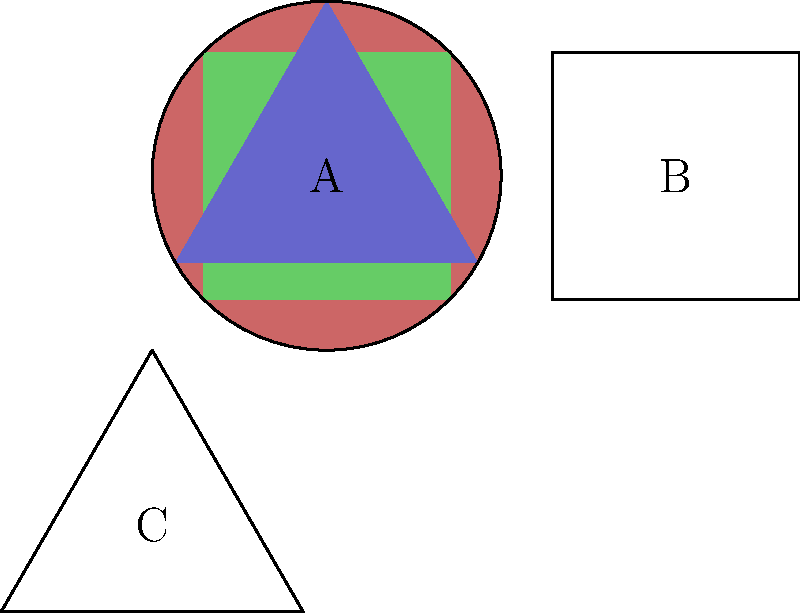Identify the rock formations A, B, and C based on their characteristic shapes. Which one represents sedimentary rock? To identify the rock formations, we need to understand the typical characteristics of each type:

1. Igneous rocks: Often form in rounded or irregular shapes due to cooling from molten material. In the image, formation A is circular, representing this type.

2. Sedimentary rocks: Typically form in layers or strata, resulting in a more rectangular or square-like appearance. In the image, formation B is square-shaped, representing this type.

3. Metamorphic rocks: Can have various shapes but are often characterized by foliation or banding, sometimes resulting in angular or triangular formations. In the image, formation C is triangular, representing this type.

Based on these characteristics, we can conclude that the sedimentary rock formation is represented by B, the square-shaped structure.
Answer: B 